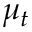Convert formula to latex. <formula><loc_0><loc_0><loc_500><loc_500>\mu _ { t }</formula> 